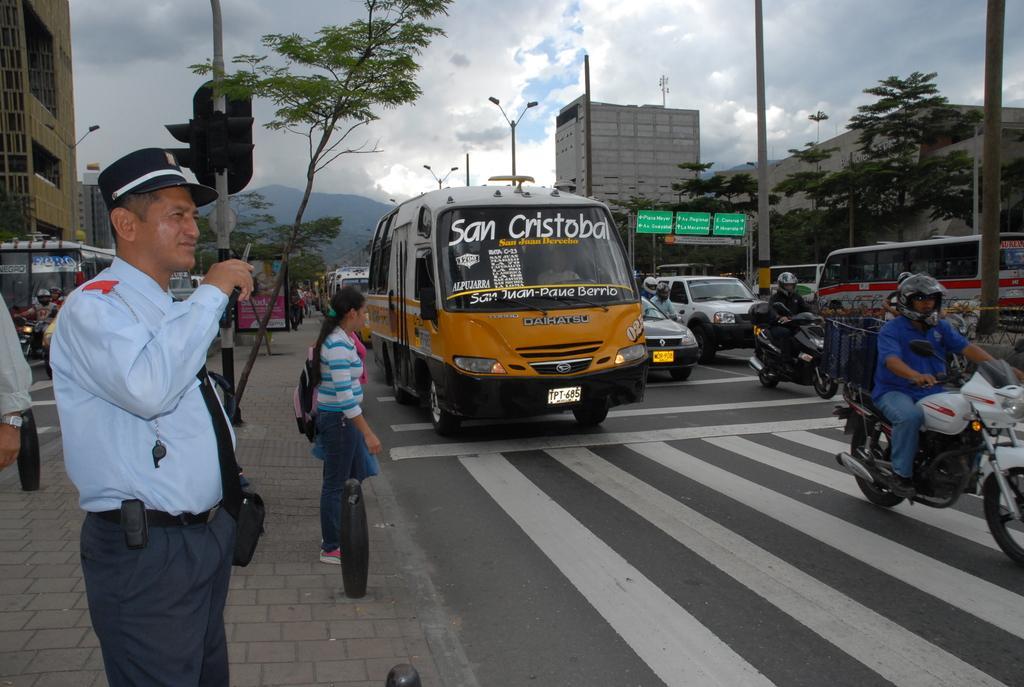In one or two sentences, can you explain what this image depicts? This is an outside view. Here I can see few vehicles on the road. In the background there are buildings. On the top of the image I can see the sky. On the left side there is a man standing. On the right side I can see poles. 